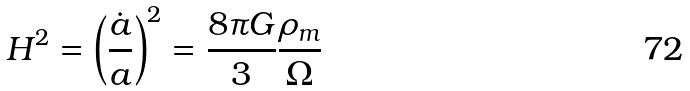Convert formula to latex. <formula><loc_0><loc_0><loc_500><loc_500>H ^ { 2 } = \left ( \frac { \dot { a } } { a } \right ) ^ { 2 } = \frac { 8 \pi G } { 3 } \frac { \rho _ { m } } { \Omega }</formula> 